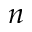Convert formula to latex. <formula><loc_0><loc_0><loc_500><loc_500>n</formula> 